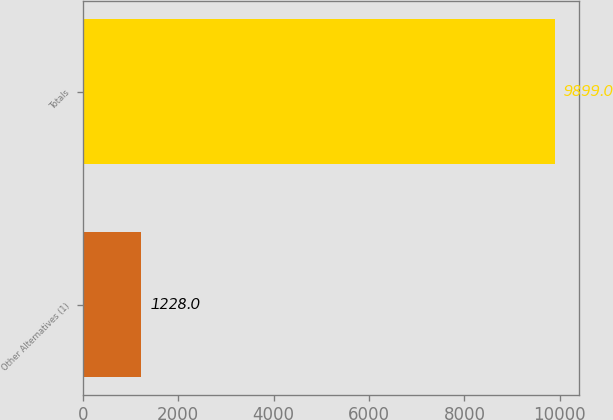Convert chart. <chart><loc_0><loc_0><loc_500><loc_500><bar_chart><fcel>Other Alternatives (1)<fcel>Totals<nl><fcel>1228<fcel>9899<nl></chart> 